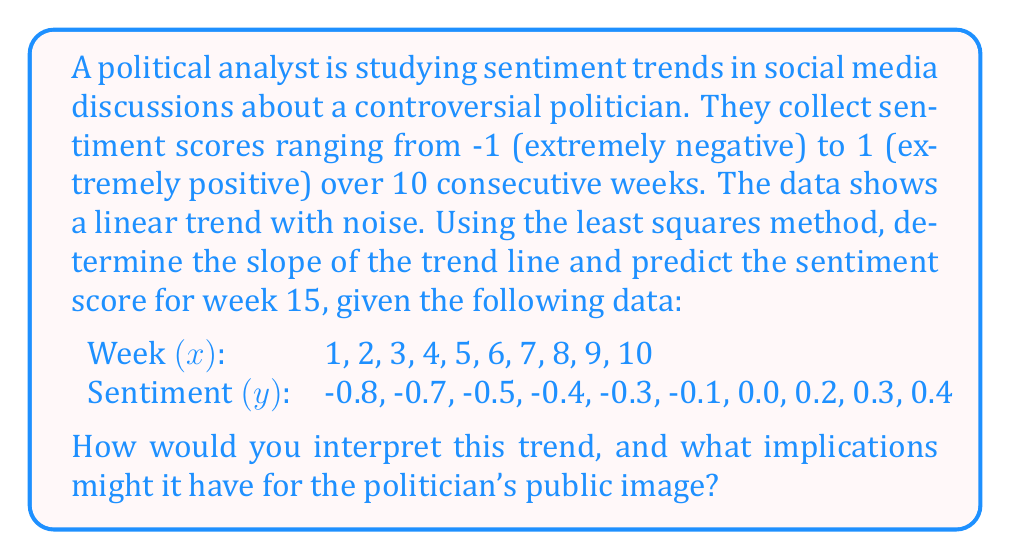What is the answer to this math problem? To solve this problem, we'll use the least squares method to find the linear trend line and make a prediction. We'll follow these steps:

1. Calculate the necessary sums:
   $$\sum x = 55, \sum y = -1.9, \sum x^2 = 385, \sum xy = -4.5, n = 10$$

2. Use the least squares formulas to find the slope (m) and y-intercept (b):
   $$m = \frac{n\sum xy - \sum x \sum y}{n\sum x^2 - (\sum x)^2}$$
   $$m = \frac{10(-4.5) - 55(-1.9)}{10(385) - 55^2} = \frac{45 - (-104.5)}{3850 - 3025} = \frac{149.5}{825} = 0.1812$$

   $$b = \frac{\sum y - m\sum x}{n}$$
   $$b = \frac{-1.9 - 0.1812(55)}{10} = \frac{-1.9 - 9.966}{10} = -1.1866$$

3. The equation of the trend line is:
   $$y = 0.1812x - 1.1866$$

4. To predict the sentiment score for week 15, substitute x = 15:
   $$y = 0.1812(15) - 1.1866 = 2.718 - 1.1866 = 1.5314$$

   However, since sentiment scores are bounded between -1 and 1, we need to cap this value at 1.

Interpretation: The positive slope (0.1812) indicates an improving trend in sentiment over time. Starting from a negative sentiment, the trend suggests a gradual shift towards more positive perceptions. By week 15, the model predicts a highly positive sentiment, although this should be interpreted cautiously due to the bounds of the sentiment scale.

Implications: This trend could suggest that the politician's public image is improving over time, possibly due to effective communication strategies or positive policy outcomes. However, it's crucial to consider other factors and potential biases in social media data before drawing definitive conclusions about public opinion.
Answer: Slope: 0.1812; Predicted sentiment for week 15: 1 (capped) 